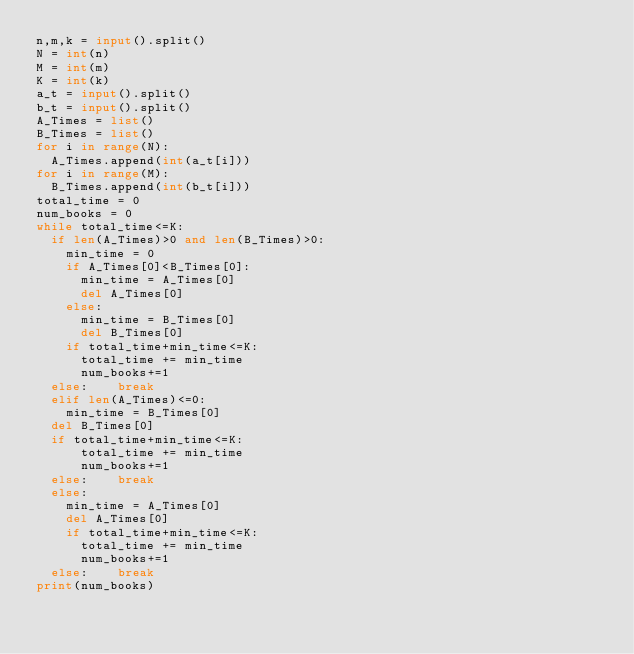<code> <loc_0><loc_0><loc_500><loc_500><_Python_>n,m,k = input().split()
N = int(n)
M = int(m)
K = int(k)
a_t = input().split()
b_t = input().split()
A_Times = list()
B_Times = list()
for i in range(N):
  A_Times.append(int(a_t[i]))
for i in range(M):
  B_Times.append(int(b_t[i]))
total_time = 0
num_books = 0
while total_time<=K:
  if len(A_Times)>0 and len(B_Times)>0:
    min_time = 0
    if A_Times[0]<B_Times[0]:
      min_time = A_Times[0]
      del A_Times[0]
    else: 
      min_time = B_Times[0]
      del B_Times[0]
    if total_time+min_time<=K:
      total_time += min_time
      num_books+=1
	else:    break
  elif len(A_Times)<=0:
    min_time = B_Times[0]
	del B_Times[0]
	if total_time+min_time<=K:
      total_time += min_time
      num_books+=1
	else:    break
  else:
    min_time = A_Times[0]
    del A_Times[0]
    if total_time+min_time<=K:
      total_time += min_time
      num_books+=1
	else:    break
print(num_books)
</code> 